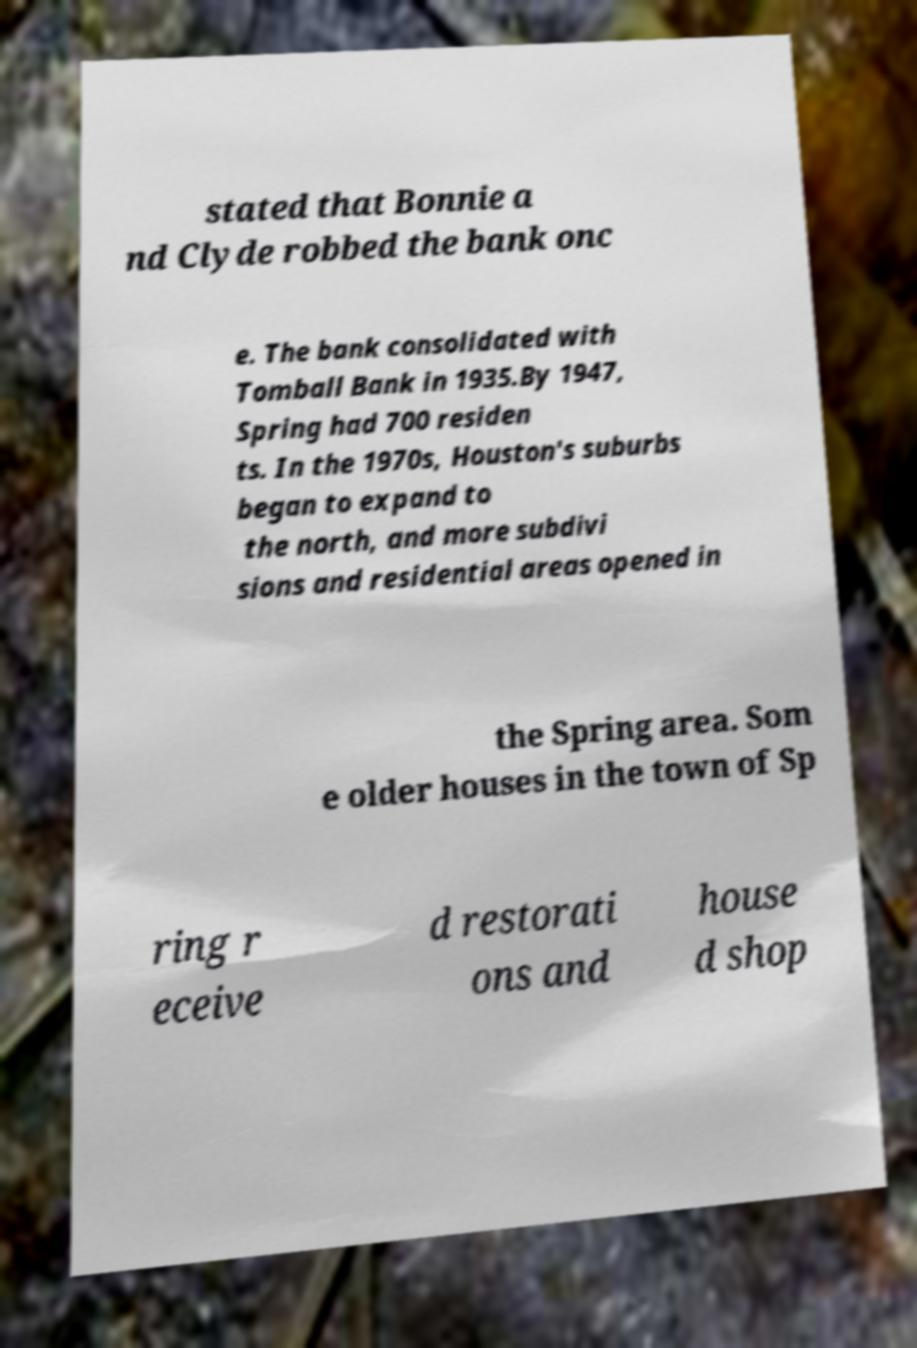For documentation purposes, I need the text within this image transcribed. Could you provide that? stated that Bonnie a nd Clyde robbed the bank onc e. The bank consolidated with Tomball Bank in 1935.By 1947, Spring had 700 residen ts. In the 1970s, Houston's suburbs began to expand to the north, and more subdivi sions and residential areas opened in the Spring area. Som e older houses in the town of Sp ring r eceive d restorati ons and house d shop 